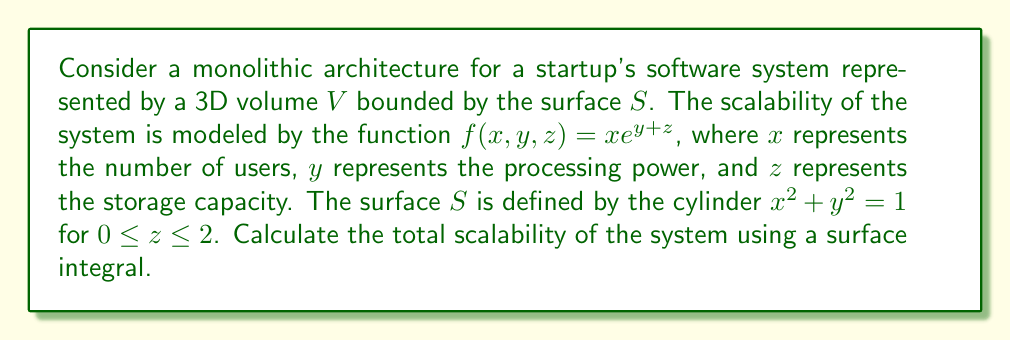Provide a solution to this math problem. To evaluate the scalability of the monolithic architecture using a surface integral, we'll follow these steps:

1) We need to use the divergence theorem, which states:
   $$\iiint_V \nabla \cdot \mathbf{F} \, dV = \iint_S \mathbf{F} \cdot \mathbf{n} \, dS$$
   where $\mathbf{F}$ is a vector field and $\mathbf{n}$ is the outward unit normal vector to the surface.

2) In our case, $\mathbf{F} = (xe^{y+z}, 0, 0)$, as we're only interested in the $x$ component.

3) Calculate the divergence of $\mathbf{F}$:
   $$\nabla \cdot \mathbf{F} = \frac{\partial}{\partial x}(xe^{y+z}) + \frac{\partial}{\partial y}(0) + \frac{\partial}{\partial z}(0) = e^{y+z}$$

4) Now, we need to evaluate the volume integral:
   $$\iiint_V e^{y+z} \, dV$$

5) Convert to cylindrical coordinates:
   $x = r\cos\theta$, $y = r\sin\theta$, $z = z$
   The Jacobian is $r$, and the limits are:
   $0 \leq r \leq 1$, $0 \leq \theta \leq 2\pi$, $0 \leq z \leq 2$

6) Evaluate the triple integral:
   $$\int_0^2 \int_0^{2\pi} \int_0^1 e^{r\sin\theta + z} r \, dr \, d\theta \, dz$$

7) Solve the integral:
   $$\int_0^2 \int_0^{2\pi} [e^{r\sin\theta + z}(r-1) + e^z]_0^1 \, d\theta \, dz$$
   $$= \int_0^2 \int_0^{2\pi} (e^{\sin\theta + z} - e^z) \, d\theta \, dz$$
   $$= \int_0^2 [2\pi e^z(I_0(1) - 1)] \, dz$$
   where $I_0(1)$ is the modified Bessel function of the first kind.

8) The final result is:
   $$2\pi(I_0(1) - 1)(e^2 - 1)$$

This value represents the total scalability of the monolithic system.
Answer: $2\pi(I_0(1) - 1)(e^2 - 1)$ 